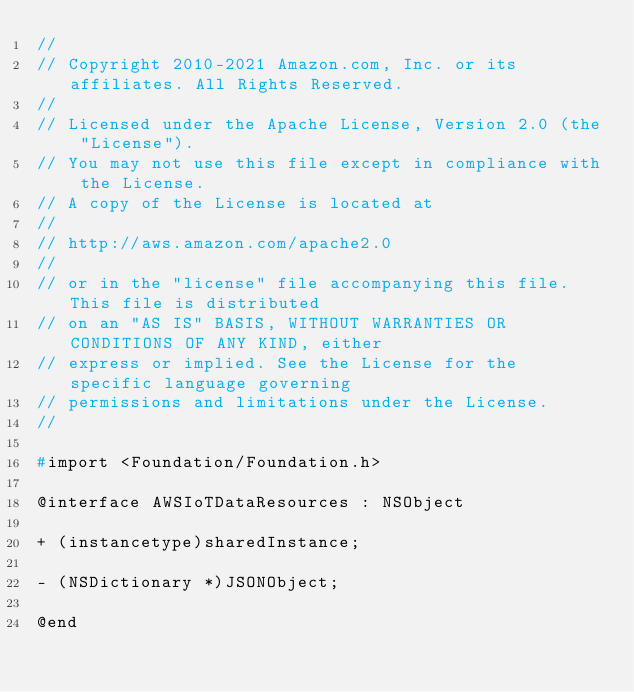<code> <loc_0><loc_0><loc_500><loc_500><_C_>//
// Copyright 2010-2021 Amazon.com, Inc. or its affiliates. All Rights Reserved.
//
// Licensed under the Apache License, Version 2.0 (the "License").
// You may not use this file except in compliance with the License.
// A copy of the License is located at
//
// http://aws.amazon.com/apache2.0
//
// or in the "license" file accompanying this file. This file is distributed
// on an "AS IS" BASIS, WITHOUT WARRANTIES OR CONDITIONS OF ANY KIND, either
// express or implied. See the License for the specific language governing
// permissions and limitations under the License.
//

#import <Foundation/Foundation.h>

@interface AWSIoTDataResources : NSObject

+ (instancetype)sharedInstance;

- (NSDictionary *)JSONObject;

@end
</code> 